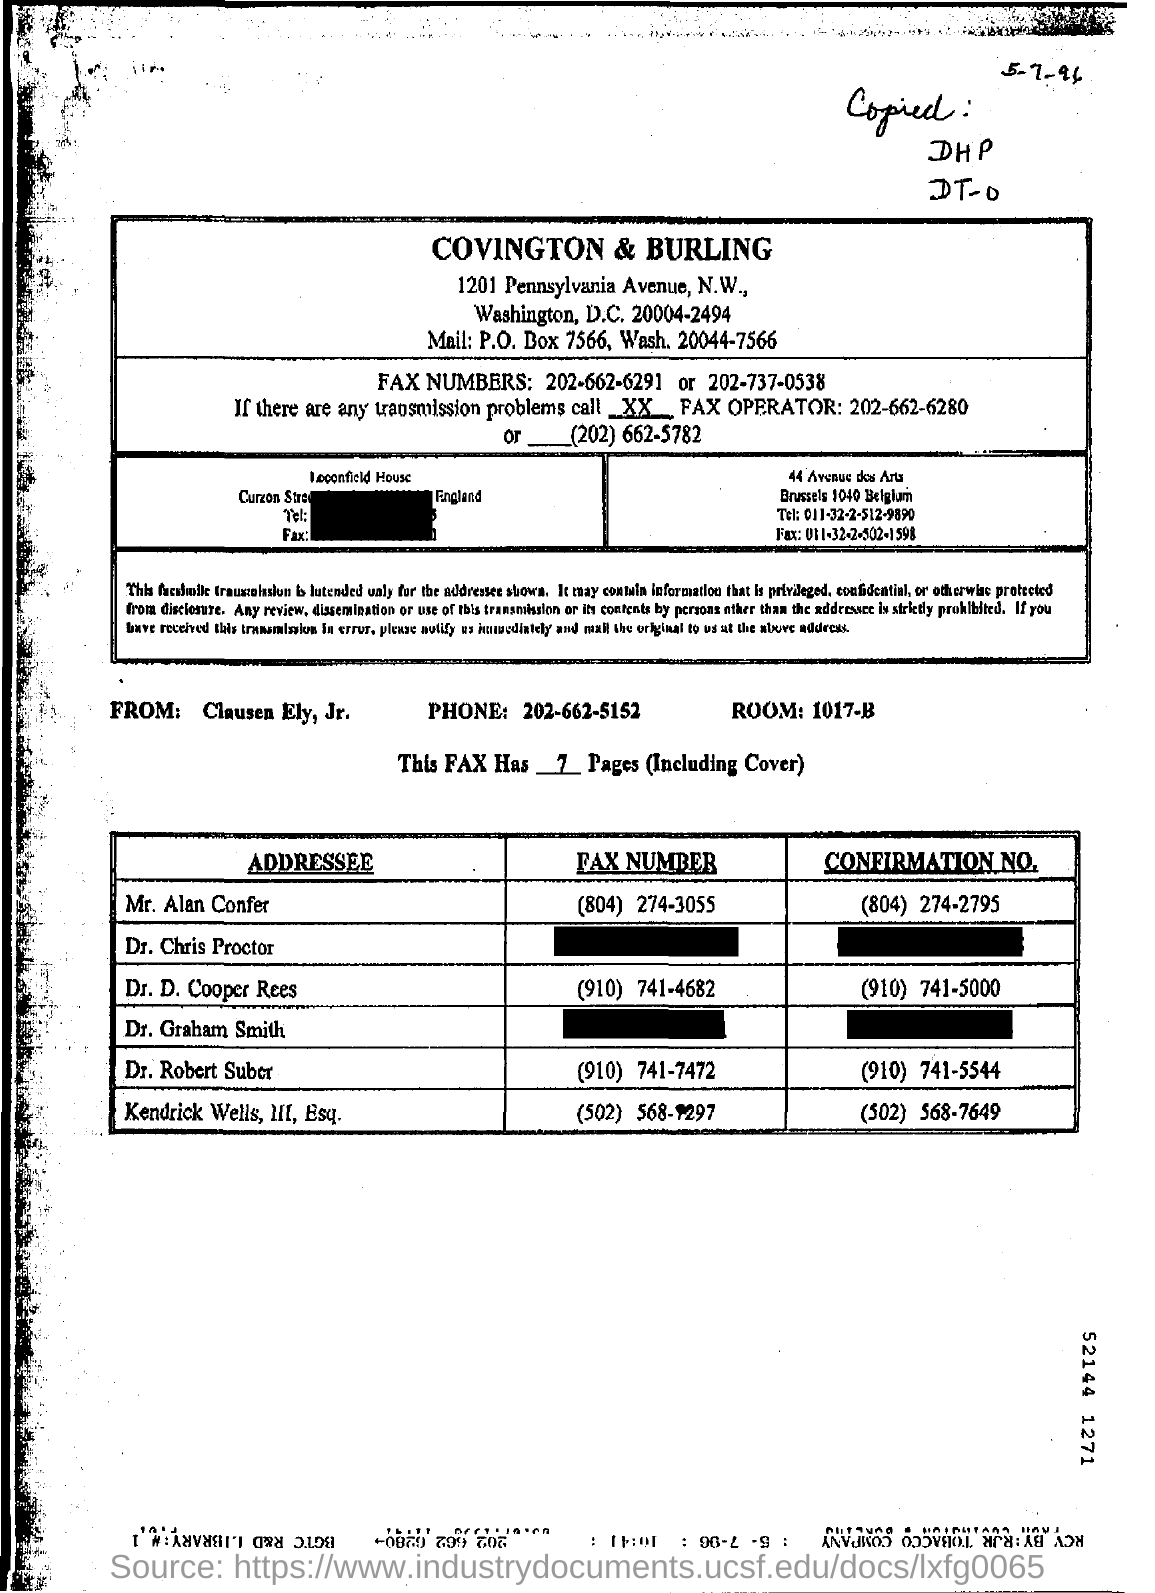Give some essential details in this illustration. The confirmation number given for Dr. D. Cooper Rees is (910) 741-5000. I request that the contact information for Clausen Ely, Jr. be provided, specifically their phone number which is 202-662-5152. The telephone number of Mr. Alan Confer is (804) 274-3055. The sender of the FAX is Clausen Ely, Jr. 